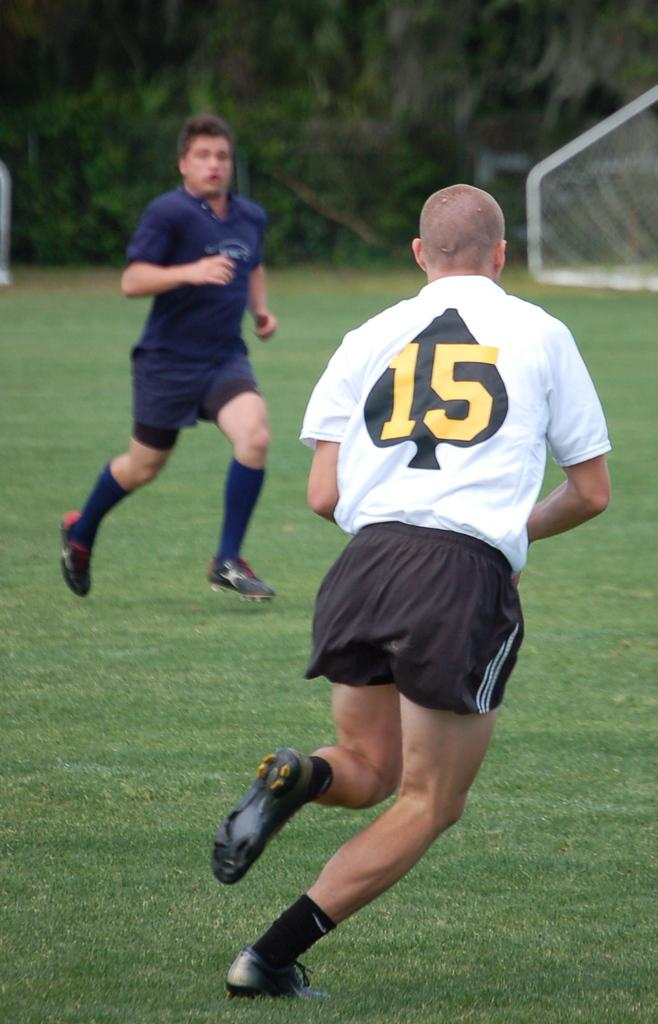What are the persons in the image doing? The persons in the image are running. What can be seen beneath the persons' feet in the image? The ground is visible in the image. What type of vegetation is present in the image? There is grass in the image. What else can be seen in the image besides the persons and the grass? There are trees and a net in the image. Can you tell me how many wings are visible on the persons in the image? There are no wings visible on the persons in the image. What type of test is being conducted in the image? There is no test being conducted in the image; it shows persons running in a grassy area with trees and a net. 